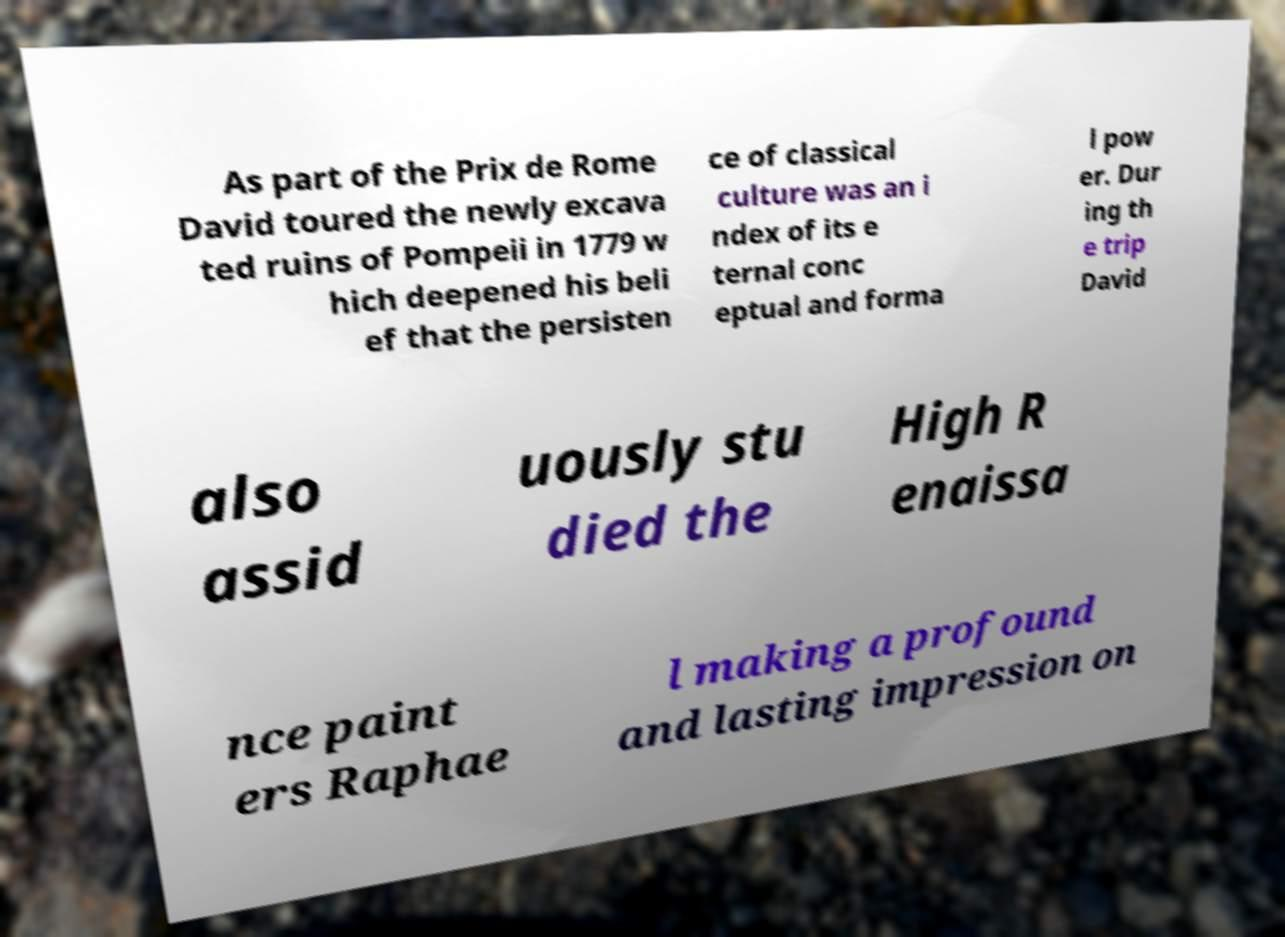Please read and relay the text visible in this image. What does it say? As part of the Prix de Rome David toured the newly excava ted ruins of Pompeii in 1779 w hich deepened his beli ef that the persisten ce of classical culture was an i ndex of its e ternal conc eptual and forma l pow er. Dur ing th e trip David also assid uously stu died the High R enaissa nce paint ers Raphae l making a profound and lasting impression on 